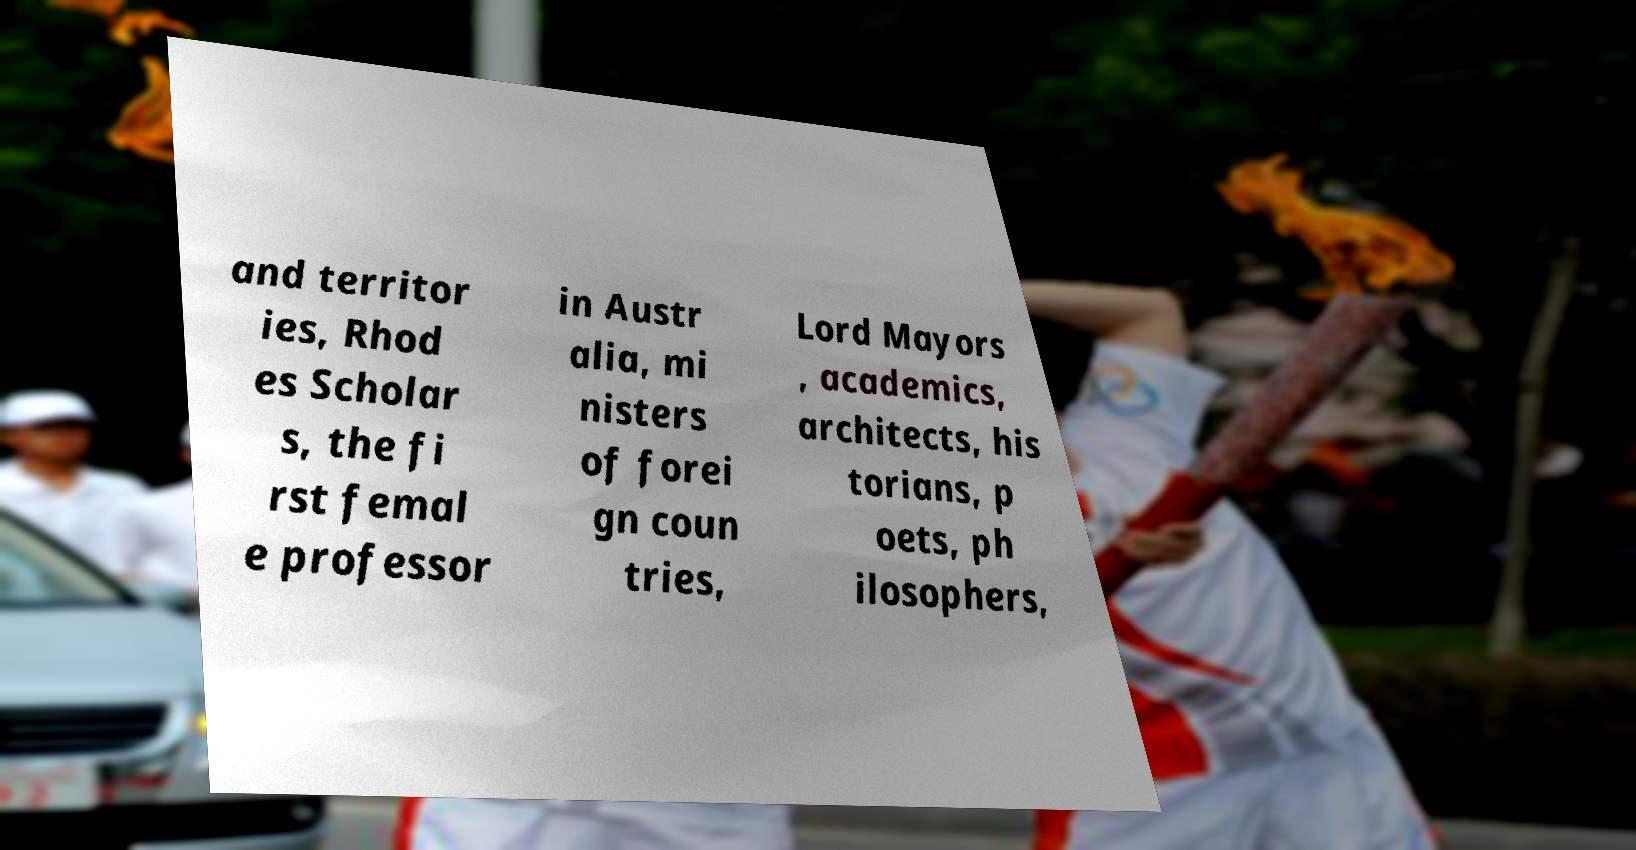What messages or text are displayed in this image? I need them in a readable, typed format. and territor ies, Rhod es Scholar s, the fi rst femal e professor in Austr alia, mi nisters of forei gn coun tries, Lord Mayors , academics, architects, his torians, p oets, ph ilosophers, 